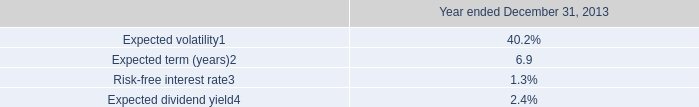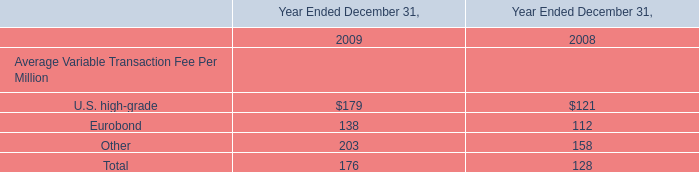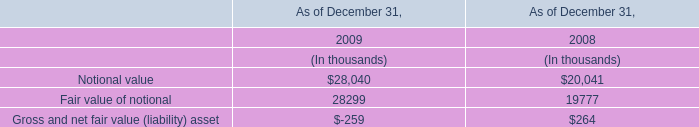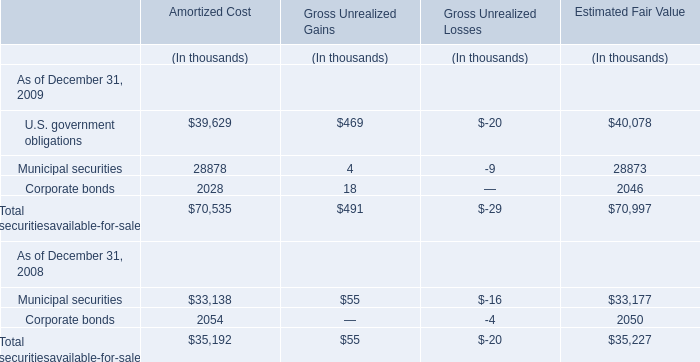What's the growth rate of Municipal securities at Estimated Fair Value between December 31, 2008 and December 31,2009 ? 
Computations: ((28873 - 33177) / 33177)
Answer: -0.12973. 